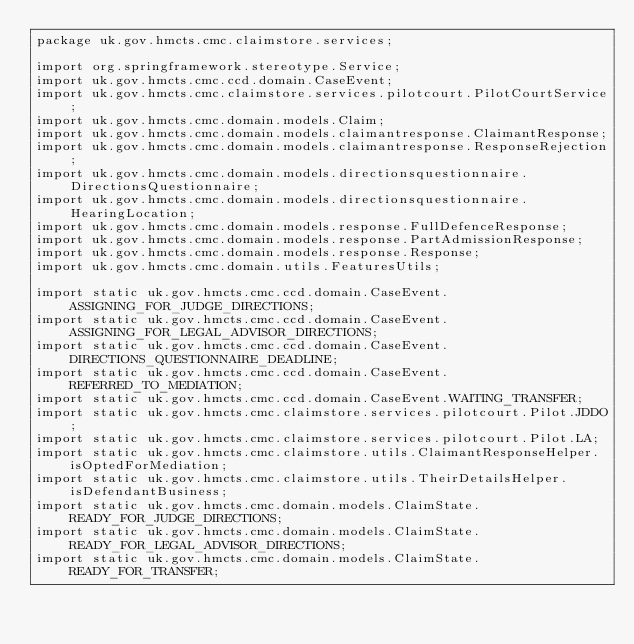Convert code to text. <code><loc_0><loc_0><loc_500><loc_500><_Java_>package uk.gov.hmcts.cmc.claimstore.services;

import org.springframework.stereotype.Service;
import uk.gov.hmcts.cmc.ccd.domain.CaseEvent;
import uk.gov.hmcts.cmc.claimstore.services.pilotcourt.PilotCourtService;
import uk.gov.hmcts.cmc.domain.models.Claim;
import uk.gov.hmcts.cmc.domain.models.claimantresponse.ClaimantResponse;
import uk.gov.hmcts.cmc.domain.models.claimantresponse.ResponseRejection;
import uk.gov.hmcts.cmc.domain.models.directionsquestionnaire.DirectionsQuestionnaire;
import uk.gov.hmcts.cmc.domain.models.directionsquestionnaire.HearingLocation;
import uk.gov.hmcts.cmc.domain.models.response.FullDefenceResponse;
import uk.gov.hmcts.cmc.domain.models.response.PartAdmissionResponse;
import uk.gov.hmcts.cmc.domain.models.response.Response;
import uk.gov.hmcts.cmc.domain.utils.FeaturesUtils;

import static uk.gov.hmcts.cmc.ccd.domain.CaseEvent.ASSIGNING_FOR_JUDGE_DIRECTIONS;
import static uk.gov.hmcts.cmc.ccd.domain.CaseEvent.ASSIGNING_FOR_LEGAL_ADVISOR_DIRECTIONS;
import static uk.gov.hmcts.cmc.ccd.domain.CaseEvent.DIRECTIONS_QUESTIONNAIRE_DEADLINE;
import static uk.gov.hmcts.cmc.ccd.domain.CaseEvent.REFERRED_TO_MEDIATION;
import static uk.gov.hmcts.cmc.ccd.domain.CaseEvent.WAITING_TRANSFER;
import static uk.gov.hmcts.cmc.claimstore.services.pilotcourt.Pilot.JDDO;
import static uk.gov.hmcts.cmc.claimstore.services.pilotcourt.Pilot.LA;
import static uk.gov.hmcts.cmc.claimstore.utils.ClaimantResponseHelper.isOptedForMediation;
import static uk.gov.hmcts.cmc.claimstore.utils.TheirDetailsHelper.isDefendantBusiness;
import static uk.gov.hmcts.cmc.domain.models.ClaimState.READY_FOR_JUDGE_DIRECTIONS;
import static uk.gov.hmcts.cmc.domain.models.ClaimState.READY_FOR_LEGAL_ADVISOR_DIRECTIONS;
import static uk.gov.hmcts.cmc.domain.models.ClaimState.READY_FOR_TRANSFER;</code> 